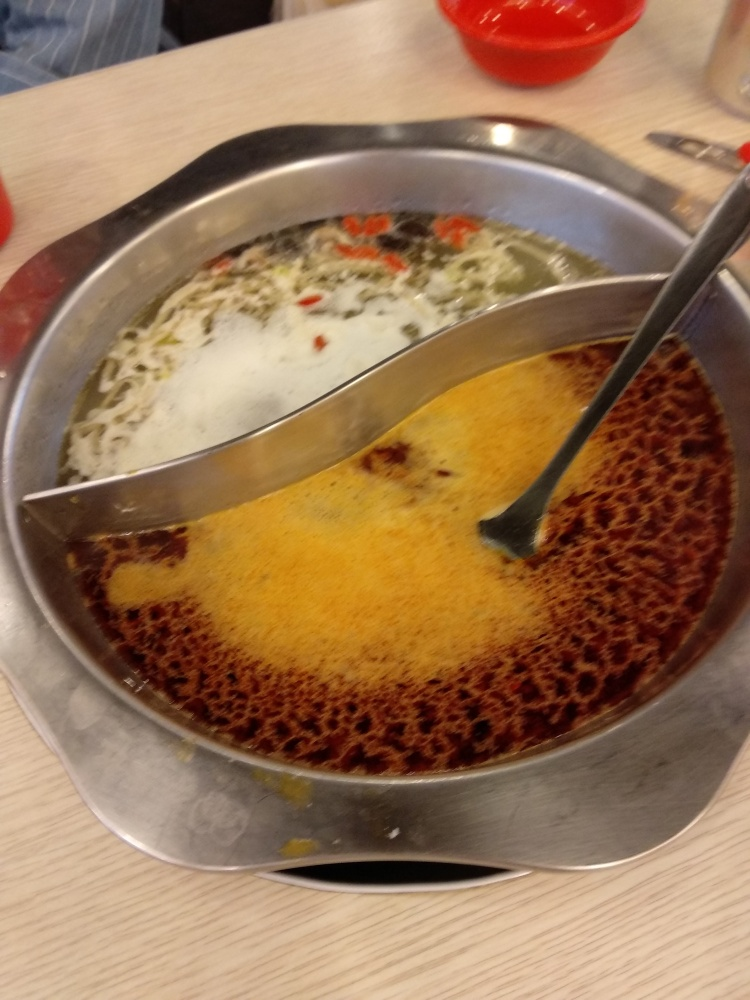What is the clarity of the image? A. acceptable B. crisp C. blurry D. perfect Answer with the option's letter from the given choices directly. The clarity of the image is closer to option C, blurry. The photo seems to have a soft focus, lacking sharpness and fine details. While it is not so unclear as to make the subject indistinguishable, the resolution and focus are not as crisp as one might prefer for a high-quality image. 